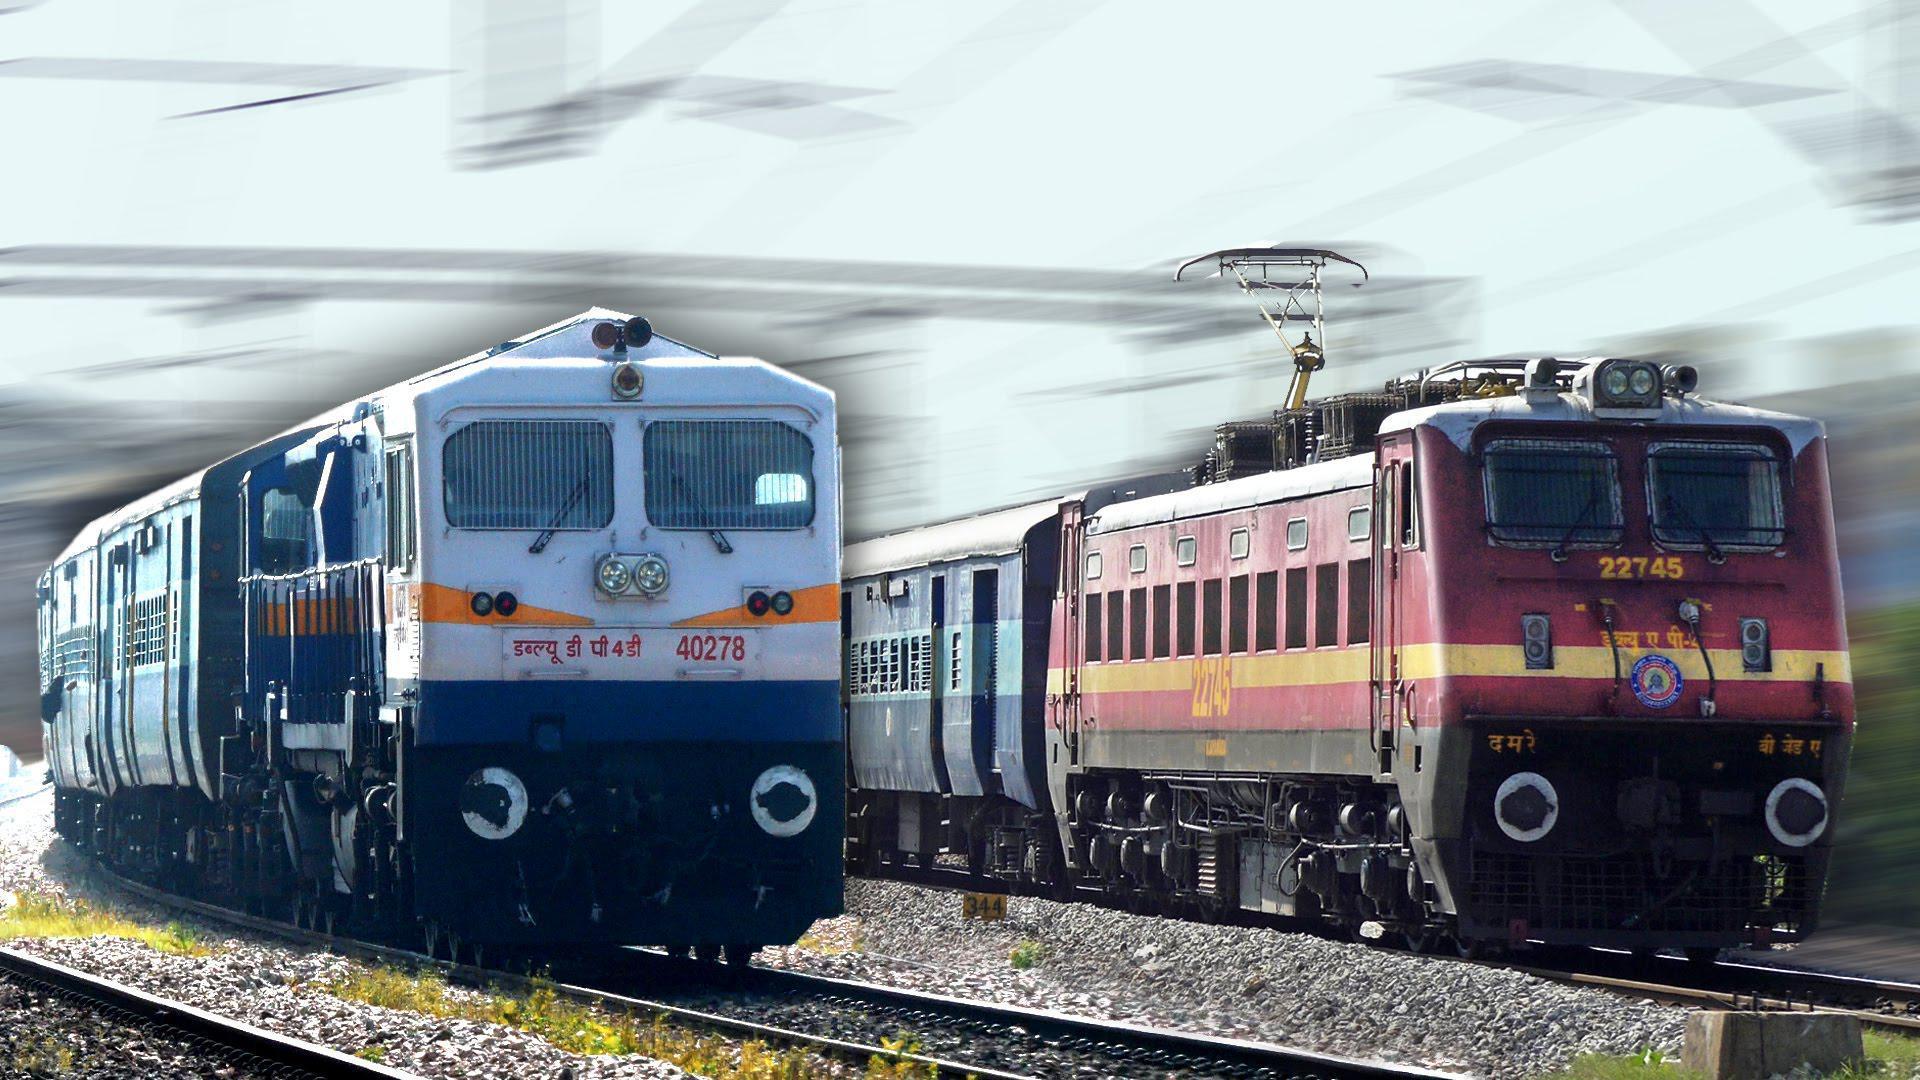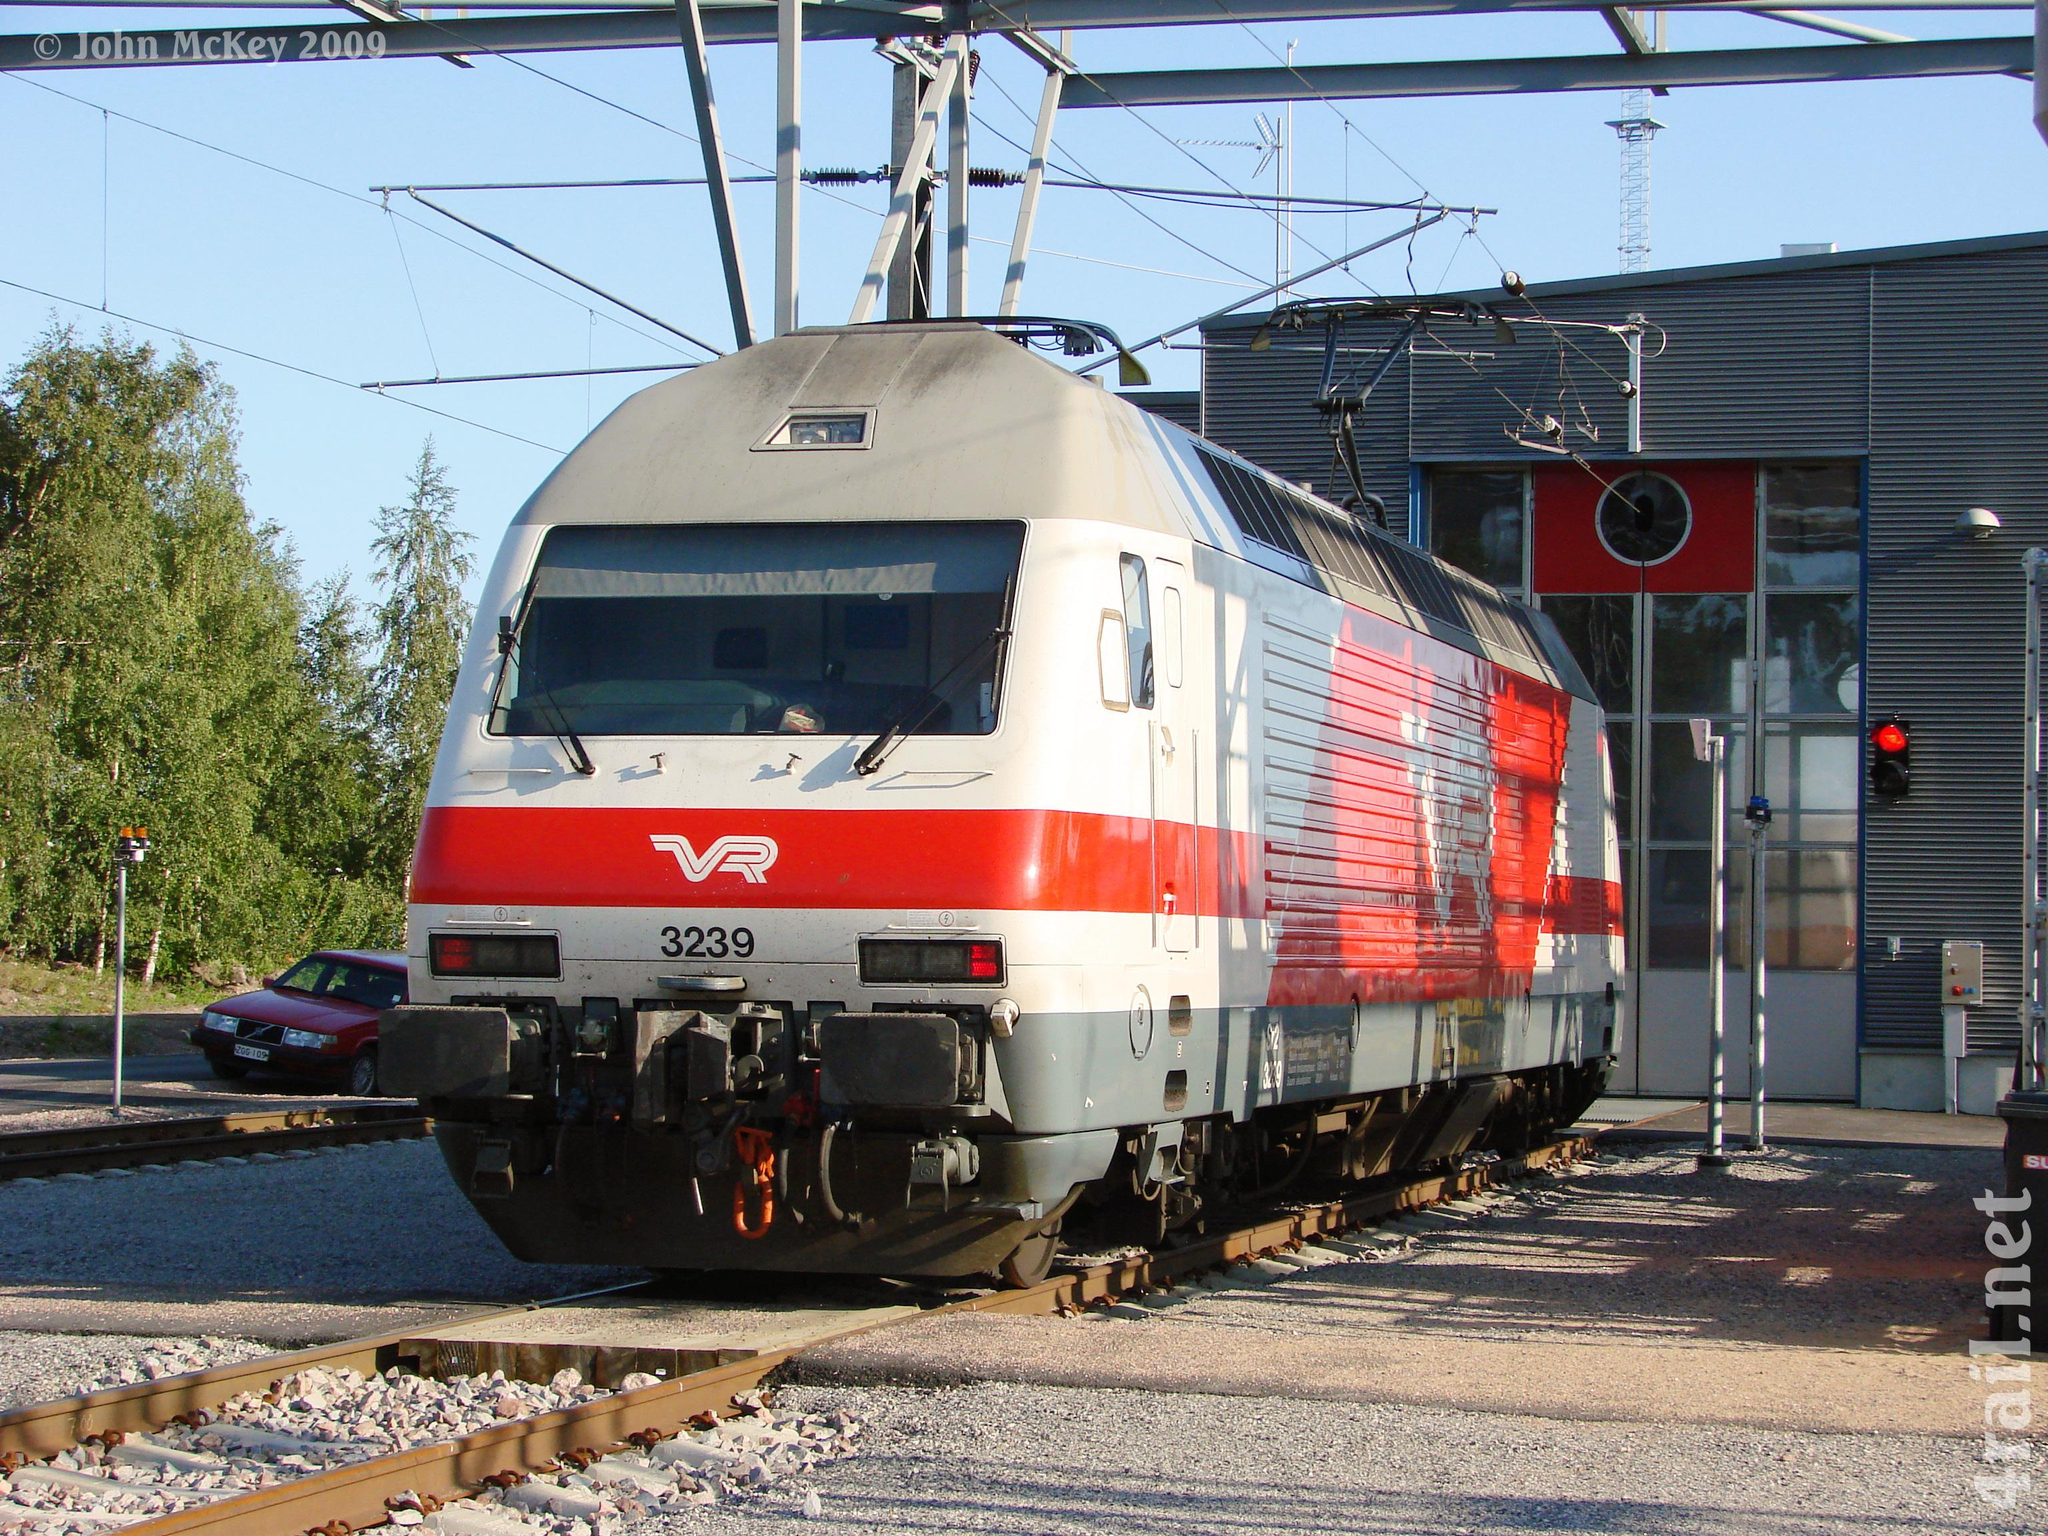The first image is the image on the left, the second image is the image on the right. For the images displayed, is the sentence "All the trains are angled in the same general direction." factually correct? Answer yes or no. No. 